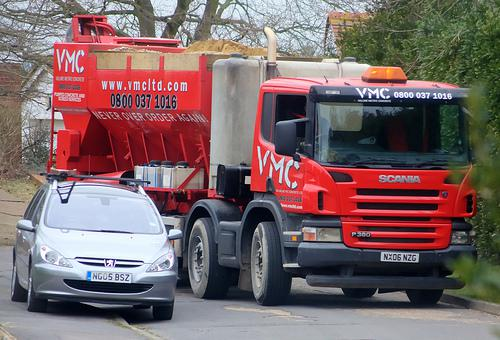Question: how many vehicles are shown?
Choices:
A. One.
B. Four.
C. Eight.
D. Two.
Answer with the letter. Answer: D Question: what vehicle has a yellow light on top of it?
Choices:
A. The truck.
B. The bus.
C. The train.
D. The taxi.
Answer with the letter. Answer: A Question: how many tires are visible?
Choices:
A. Two.
B. One.
C. Four.
D. Seven.
Answer with the letter. Answer: D Question: when was the photo taken?
Choices:
A. At night time.
B. In the morning.
C. During the day.
D. During lunch.
Answer with the letter. Answer: C Question: where does the number 0800 037 1016 appear?
Choices:
A. On the cockpit of the airplane.
B. On the sign.
C. On the front and side of the truck.
D. On the paper.
Answer with the letter. Answer: C 